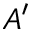<formula> <loc_0><loc_0><loc_500><loc_500>A ^ { \prime }</formula> 